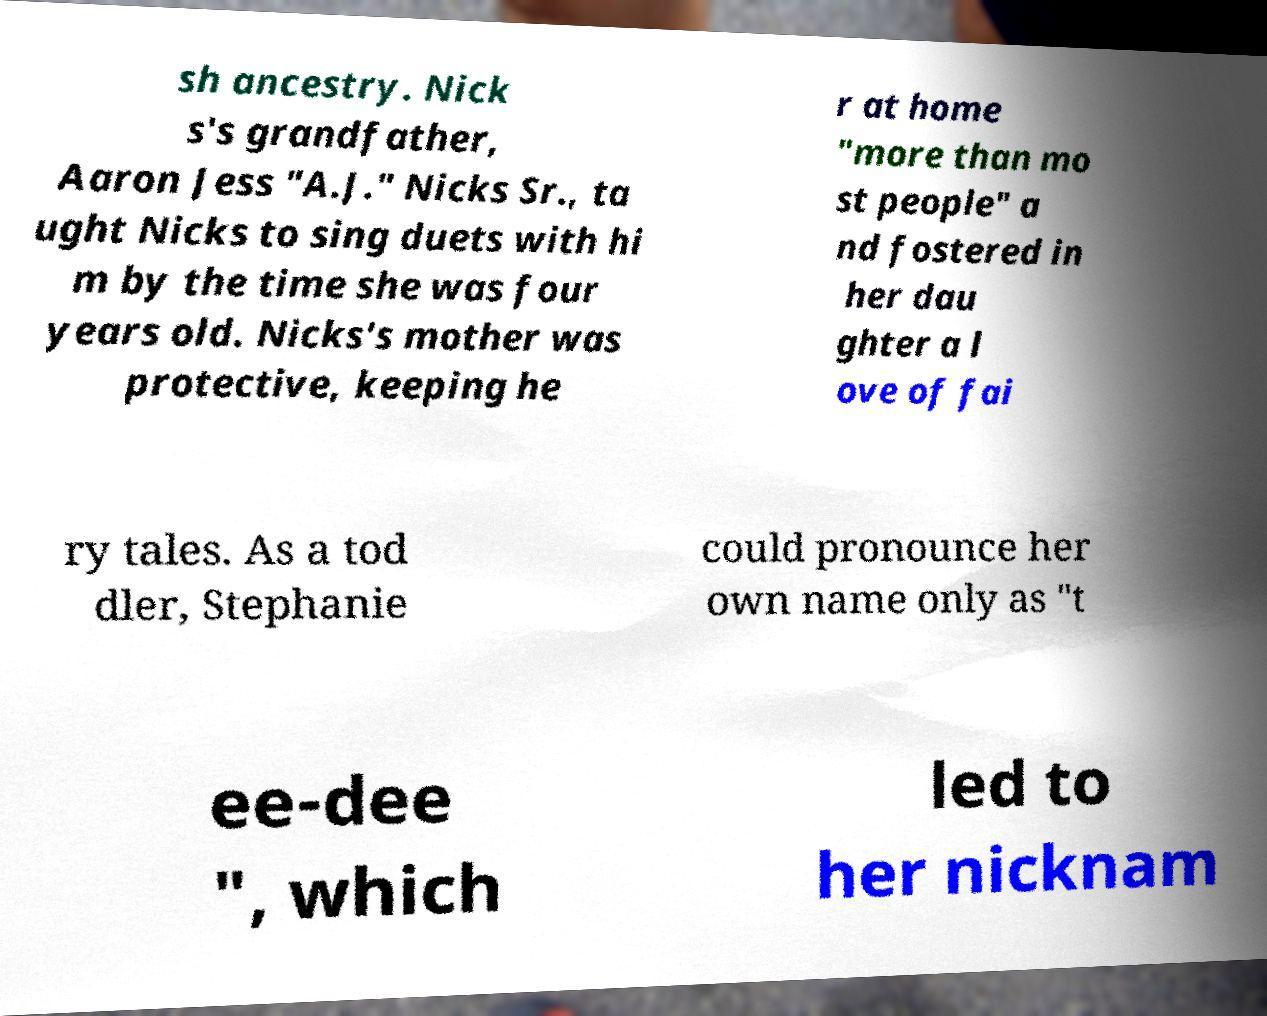I need the written content from this picture converted into text. Can you do that? sh ancestry. Nick s's grandfather, Aaron Jess "A.J." Nicks Sr., ta ught Nicks to sing duets with hi m by the time she was four years old. Nicks's mother was protective, keeping he r at home "more than mo st people" a nd fostered in her dau ghter a l ove of fai ry tales. As a tod dler, Stephanie could pronounce her own name only as "t ee-dee ", which led to her nicknam 